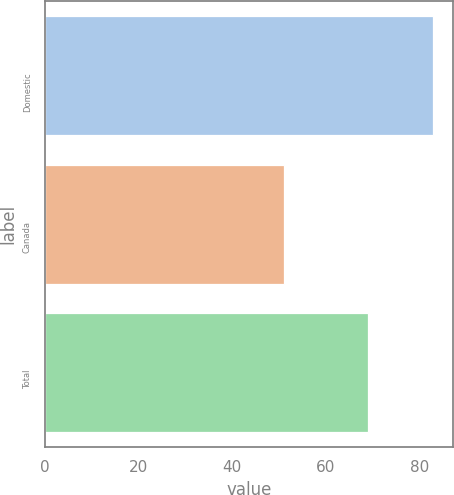Convert chart. <chart><loc_0><loc_0><loc_500><loc_500><bar_chart><fcel>Domestic<fcel>Canada<fcel>Total<nl><fcel>83<fcel>51<fcel>69<nl></chart> 